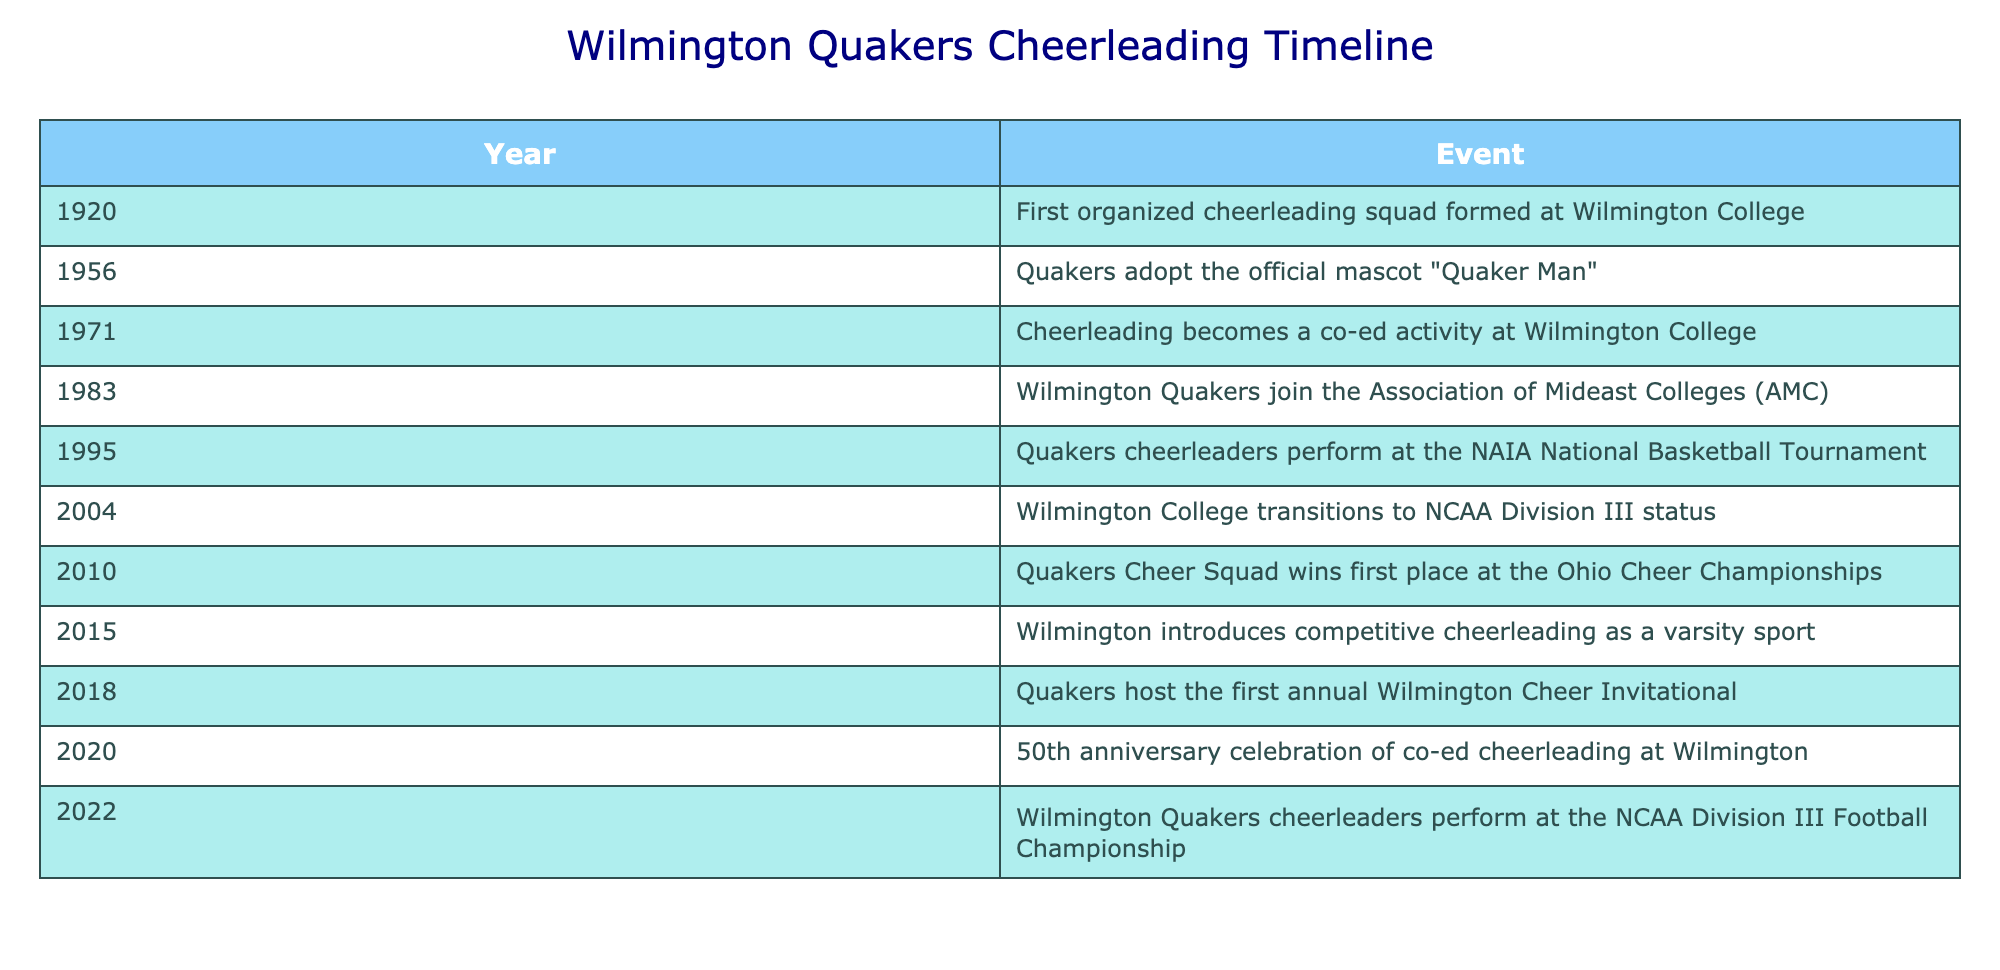What year was the first organized cheerleading squad formed at Wilmington College? The table clearly states that the first organized cheerleading squad was formed in the year 1920.
Answer: 1920 Which event marked the adoption of the official mascot for the Quakers? Referring to the table, the event where the Quakers adopted the official mascot "Quaker Man" occurred in 1956.
Answer: 1956 How many years passed between the first organized cheerleading squad and the year co-ed cheerleading was introduced? The first organized cheerleading squad was formed in 1920, and co-ed cheerleading was introduced in 1971. The time difference is 1971 - 1920 = 51 years.
Answer: 51 years Did the Wilmington Quakers perform at the NAIA National Basketball Tournament before or after transitioning to NCAA Division III status? According to the table, the Quakers cheerleaders performed at the NAIA tournament in 1995 and transitioned to NCAA Division III status in 2004. Therefore, the performance occurred before the transition.
Answer: Before What notable event took place in 2010 for the Quakers Cheer Squad? The table indicates that in 2010, the Quakers Cheer Squad won first place at the Ohio Cheer Championships.
Answer: Quakers Cheer Squad won first place How many significant events happened in the 2010s according to the table? Reviewing the table, from 2010 to 2019, there are three significant events noted: 2010 (first place at Ohio Cheer Championships), 2015 (competitive cheerleading introduced as a varsity sport), and 2018 (first annual Wilmington Cheer Invitational).
Answer: 3 events What was the purpose of the event in 2020 for co-ed cheerleading at Wilmington? The table states that 2020 marked the 50th anniversary celebration of co-ed cheerleading at Wilmington, indicating it was a commemorative event.
Answer: 50th anniversary celebration Was there any performance by the Quakers cheerleaders at the NCAA Division III Football Championship? Yes, the table shows that the Wilmington Quakers cheerleaders performed at the NCAA Division III Football Championship in 2022, indicating they indeed participated in such an event.
Answer: Yes How many years were there between the introduction of competitive cheerleading as a varsity sport and the Quakers hosting their first annual cheer invitational? Competitive cheerleading was introduced in 2015, and the first annual cheer invitational was hosted in 2018. Therefore, the difference in years is 2018 - 2015 = 3 years.
Answer: 3 years 